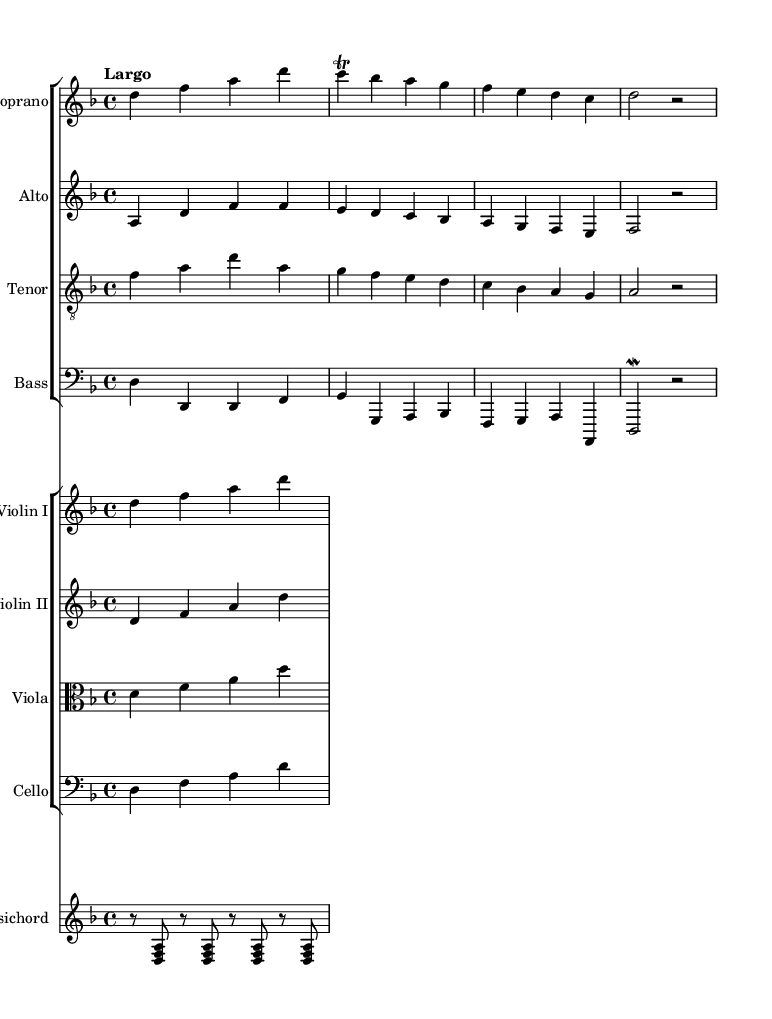What is the key signature of this music? The key signature is indicated at the beginning of the score. It shows two flats, which corresponds to the key of D minor.
Answer: D minor What is the time signature of this piece? The time signature appears at the start of the score, where it shows a 4 over 4, indicating four beats per measure.
Answer: 4/4 What is the tempo marking for this composition? The tempo marking is written above the staff and states "Largo," which indicates a slow tempo.
Answer: Largo How many instruments are present in this score? By counting the number of individual staves in the score, including the choir and instrumental sections, we find there are eight instruments in total.
Answer: Eight instruments Which vocal part has the lowest pitch range? The bass part, notated on the bass clef, typically has the lowest pitch range in choral compositions. By identifying the clef, we can determine that the bass part is lower than the others.
Answer: Bass What text is set to the given melody? The lyrics are directly aligned with the melody in the score, starting with "O Constan..." and detailing the entire phrase. By examining the lyric mode section, the text can be identified.
Answer: O Constan.. What is the significance of the word "Conquerors" in the lyrics? The term "Conquerors" reflects a historical tragedy depicted in the opera, suggesting themes of defeat and loss, directly relating to the operatic works' subject matter. Such connections deepen the understanding of the emotional weight of the music.
Answer: Conquerors 